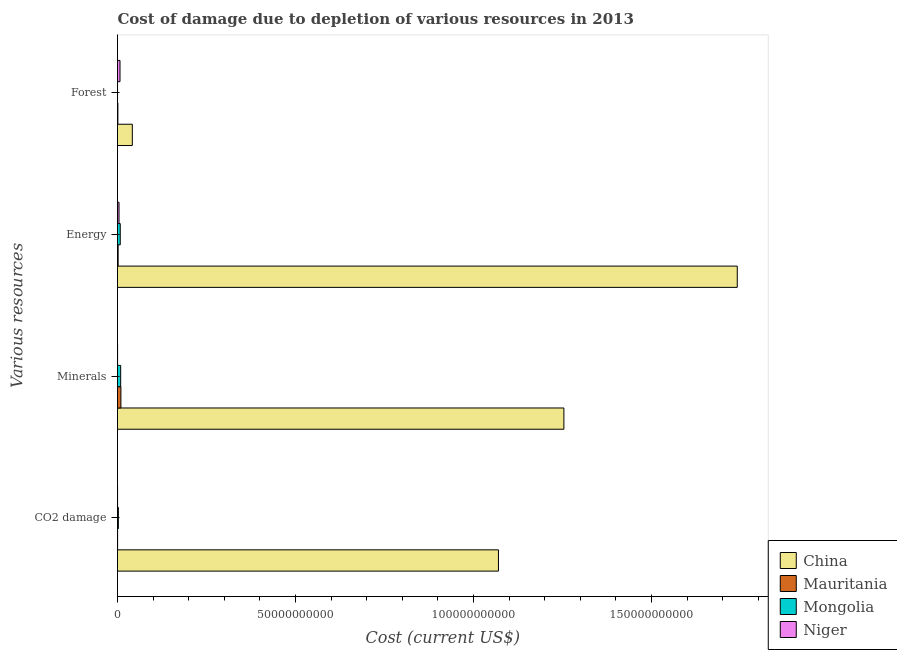How many different coloured bars are there?
Offer a terse response. 4. How many groups of bars are there?
Offer a very short reply. 4. What is the label of the 2nd group of bars from the top?
Keep it short and to the point. Energy. What is the cost of damage due to depletion of coal in Mongolia?
Your answer should be compact. 2.45e+08. Across all countries, what is the maximum cost of damage due to depletion of energy?
Offer a very short reply. 1.74e+11. Across all countries, what is the minimum cost of damage due to depletion of coal?
Provide a short and direct response. 1.70e+07. In which country was the cost of damage due to depletion of minerals minimum?
Ensure brevity in your answer.  Niger. What is the total cost of damage due to depletion of energy in the graph?
Give a very brief answer. 1.75e+11. What is the difference between the cost of damage due to depletion of forests in China and that in Mongolia?
Give a very brief answer. 4.15e+09. What is the difference between the cost of damage due to depletion of energy in Mongolia and the cost of damage due to depletion of minerals in Niger?
Your answer should be compact. 7.47e+08. What is the average cost of damage due to depletion of energy per country?
Ensure brevity in your answer.  4.39e+1. What is the difference between the cost of damage due to depletion of minerals and cost of damage due to depletion of coal in Mauritania?
Keep it short and to the point. 9.31e+08. In how many countries, is the cost of damage due to depletion of forests greater than 150000000000 US$?
Ensure brevity in your answer.  0. What is the ratio of the cost of damage due to depletion of minerals in Mauritania to that in Mongolia?
Your response must be concise. 1.08. What is the difference between the highest and the second highest cost of damage due to depletion of coal?
Keep it short and to the point. 1.07e+11. What is the difference between the highest and the lowest cost of damage due to depletion of forests?
Keep it short and to the point. 4.15e+09. In how many countries, is the cost of damage due to depletion of energy greater than the average cost of damage due to depletion of energy taken over all countries?
Give a very brief answer. 1. Is the sum of the cost of damage due to depletion of energy in Mongolia and Niger greater than the maximum cost of damage due to depletion of forests across all countries?
Provide a short and direct response. No. Is it the case that in every country, the sum of the cost of damage due to depletion of energy and cost of damage due to depletion of coal is greater than the sum of cost of damage due to depletion of minerals and cost of damage due to depletion of forests?
Offer a terse response. No. What does the 3rd bar from the top in Forest represents?
Give a very brief answer. Mauritania. What does the 2nd bar from the bottom in Forest represents?
Give a very brief answer. Mauritania. Is it the case that in every country, the sum of the cost of damage due to depletion of coal and cost of damage due to depletion of minerals is greater than the cost of damage due to depletion of energy?
Make the answer very short. No. Are all the bars in the graph horizontal?
Ensure brevity in your answer.  Yes. Are the values on the major ticks of X-axis written in scientific E-notation?
Make the answer very short. No. Does the graph contain grids?
Your answer should be very brief. No. Where does the legend appear in the graph?
Your answer should be compact. Bottom right. How are the legend labels stacked?
Provide a succinct answer. Vertical. What is the title of the graph?
Your response must be concise. Cost of damage due to depletion of various resources in 2013 . Does "Macao" appear as one of the legend labels in the graph?
Make the answer very short. No. What is the label or title of the X-axis?
Provide a succinct answer. Cost (current US$). What is the label or title of the Y-axis?
Your answer should be very brief. Various resources. What is the Cost (current US$) of China in CO2 damage?
Keep it short and to the point. 1.07e+11. What is the Cost (current US$) in Mauritania in CO2 damage?
Ensure brevity in your answer.  2.65e+07. What is the Cost (current US$) in Mongolia in CO2 damage?
Your answer should be very brief. 2.45e+08. What is the Cost (current US$) of Niger in CO2 damage?
Your response must be concise. 1.70e+07. What is the Cost (current US$) of China in Minerals?
Your answer should be very brief. 1.25e+11. What is the Cost (current US$) in Mauritania in Minerals?
Keep it short and to the point. 9.57e+08. What is the Cost (current US$) in Mongolia in Minerals?
Ensure brevity in your answer.  8.90e+08. What is the Cost (current US$) of Niger in Minerals?
Provide a short and direct response. 2.19e+07. What is the Cost (current US$) in China in Energy?
Your response must be concise. 1.74e+11. What is the Cost (current US$) of Mauritania in Energy?
Offer a terse response. 1.78e+08. What is the Cost (current US$) in Mongolia in Energy?
Ensure brevity in your answer.  7.69e+08. What is the Cost (current US$) in Niger in Energy?
Make the answer very short. 4.27e+08. What is the Cost (current US$) of China in Forest?
Keep it short and to the point. 4.16e+09. What is the Cost (current US$) in Mauritania in Forest?
Give a very brief answer. 1.03e+08. What is the Cost (current US$) of Mongolia in Forest?
Provide a succinct answer. 8.40e+06. What is the Cost (current US$) in Niger in Forest?
Give a very brief answer. 7.01e+08. Across all Various resources, what is the maximum Cost (current US$) in China?
Offer a very short reply. 1.74e+11. Across all Various resources, what is the maximum Cost (current US$) of Mauritania?
Your answer should be compact. 9.57e+08. Across all Various resources, what is the maximum Cost (current US$) of Mongolia?
Offer a terse response. 8.90e+08. Across all Various resources, what is the maximum Cost (current US$) in Niger?
Make the answer very short. 7.01e+08. Across all Various resources, what is the minimum Cost (current US$) of China?
Give a very brief answer. 4.16e+09. Across all Various resources, what is the minimum Cost (current US$) in Mauritania?
Your answer should be compact. 2.65e+07. Across all Various resources, what is the minimum Cost (current US$) in Mongolia?
Offer a very short reply. 8.40e+06. Across all Various resources, what is the minimum Cost (current US$) in Niger?
Your answer should be very brief. 1.70e+07. What is the total Cost (current US$) in China in the graph?
Give a very brief answer. 4.11e+11. What is the total Cost (current US$) in Mauritania in the graph?
Provide a short and direct response. 1.27e+09. What is the total Cost (current US$) in Mongolia in the graph?
Provide a short and direct response. 1.91e+09. What is the total Cost (current US$) of Niger in the graph?
Give a very brief answer. 1.17e+09. What is the difference between the Cost (current US$) of China in CO2 damage and that in Minerals?
Your response must be concise. -1.84e+1. What is the difference between the Cost (current US$) of Mauritania in CO2 damage and that in Minerals?
Provide a short and direct response. -9.31e+08. What is the difference between the Cost (current US$) of Mongolia in CO2 damage and that in Minerals?
Keep it short and to the point. -6.46e+08. What is the difference between the Cost (current US$) in Niger in CO2 damage and that in Minerals?
Provide a short and direct response. -4.85e+06. What is the difference between the Cost (current US$) of China in CO2 damage and that in Energy?
Make the answer very short. -6.71e+1. What is the difference between the Cost (current US$) in Mauritania in CO2 damage and that in Energy?
Your response must be concise. -1.52e+08. What is the difference between the Cost (current US$) of Mongolia in CO2 damage and that in Energy?
Offer a very short reply. -5.25e+08. What is the difference between the Cost (current US$) in Niger in CO2 damage and that in Energy?
Offer a very short reply. -4.10e+08. What is the difference between the Cost (current US$) of China in CO2 damage and that in Forest?
Your response must be concise. 1.03e+11. What is the difference between the Cost (current US$) in Mauritania in CO2 damage and that in Forest?
Provide a short and direct response. -7.63e+07. What is the difference between the Cost (current US$) of Mongolia in CO2 damage and that in Forest?
Ensure brevity in your answer.  2.36e+08. What is the difference between the Cost (current US$) in Niger in CO2 damage and that in Forest?
Keep it short and to the point. -6.84e+08. What is the difference between the Cost (current US$) in China in Minerals and that in Energy?
Provide a succinct answer. -4.87e+1. What is the difference between the Cost (current US$) of Mauritania in Minerals and that in Energy?
Give a very brief answer. 7.79e+08. What is the difference between the Cost (current US$) of Mongolia in Minerals and that in Energy?
Your answer should be compact. 1.21e+08. What is the difference between the Cost (current US$) of Niger in Minerals and that in Energy?
Make the answer very short. -4.05e+08. What is the difference between the Cost (current US$) in China in Minerals and that in Forest?
Your answer should be compact. 1.21e+11. What is the difference between the Cost (current US$) of Mauritania in Minerals and that in Forest?
Give a very brief answer. 8.55e+08. What is the difference between the Cost (current US$) of Mongolia in Minerals and that in Forest?
Your response must be concise. 8.82e+08. What is the difference between the Cost (current US$) of Niger in Minerals and that in Forest?
Give a very brief answer. -6.79e+08. What is the difference between the Cost (current US$) in China in Energy and that in Forest?
Provide a succinct answer. 1.70e+11. What is the difference between the Cost (current US$) of Mauritania in Energy and that in Forest?
Provide a short and direct response. 7.56e+07. What is the difference between the Cost (current US$) of Mongolia in Energy and that in Forest?
Ensure brevity in your answer.  7.61e+08. What is the difference between the Cost (current US$) in Niger in Energy and that in Forest?
Provide a short and direct response. -2.74e+08. What is the difference between the Cost (current US$) in China in CO2 damage and the Cost (current US$) in Mauritania in Minerals?
Provide a short and direct response. 1.06e+11. What is the difference between the Cost (current US$) in China in CO2 damage and the Cost (current US$) in Mongolia in Minerals?
Provide a succinct answer. 1.06e+11. What is the difference between the Cost (current US$) of China in CO2 damage and the Cost (current US$) of Niger in Minerals?
Offer a terse response. 1.07e+11. What is the difference between the Cost (current US$) in Mauritania in CO2 damage and the Cost (current US$) in Mongolia in Minerals?
Your response must be concise. -8.64e+08. What is the difference between the Cost (current US$) of Mauritania in CO2 damage and the Cost (current US$) of Niger in Minerals?
Provide a succinct answer. 4.59e+06. What is the difference between the Cost (current US$) in Mongolia in CO2 damage and the Cost (current US$) in Niger in Minerals?
Give a very brief answer. 2.23e+08. What is the difference between the Cost (current US$) of China in CO2 damage and the Cost (current US$) of Mauritania in Energy?
Provide a succinct answer. 1.07e+11. What is the difference between the Cost (current US$) of China in CO2 damage and the Cost (current US$) of Mongolia in Energy?
Keep it short and to the point. 1.06e+11. What is the difference between the Cost (current US$) in China in CO2 damage and the Cost (current US$) in Niger in Energy?
Your answer should be compact. 1.07e+11. What is the difference between the Cost (current US$) in Mauritania in CO2 damage and the Cost (current US$) in Mongolia in Energy?
Your response must be concise. -7.43e+08. What is the difference between the Cost (current US$) in Mauritania in CO2 damage and the Cost (current US$) in Niger in Energy?
Keep it short and to the point. -4.01e+08. What is the difference between the Cost (current US$) in Mongolia in CO2 damage and the Cost (current US$) in Niger in Energy?
Offer a very short reply. -1.83e+08. What is the difference between the Cost (current US$) of China in CO2 damage and the Cost (current US$) of Mauritania in Forest?
Your answer should be compact. 1.07e+11. What is the difference between the Cost (current US$) in China in CO2 damage and the Cost (current US$) in Mongolia in Forest?
Your answer should be compact. 1.07e+11. What is the difference between the Cost (current US$) of China in CO2 damage and the Cost (current US$) of Niger in Forest?
Ensure brevity in your answer.  1.06e+11. What is the difference between the Cost (current US$) of Mauritania in CO2 damage and the Cost (current US$) of Mongolia in Forest?
Keep it short and to the point. 1.81e+07. What is the difference between the Cost (current US$) in Mauritania in CO2 damage and the Cost (current US$) in Niger in Forest?
Make the answer very short. -6.75e+08. What is the difference between the Cost (current US$) of Mongolia in CO2 damage and the Cost (current US$) of Niger in Forest?
Keep it short and to the point. -4.57e+08. What is the difference between the Cost (current US$) in China in Minerals and the Cost (current US$) in Mauritania in Energy?
Give a very brief answer. 1.25e+11. What is the difference between the Cost (current US$) in China in Minerals and the Cost (current US$) in Mongolia in Energy?
Your answer should be very brief. 1.25e+11. What is the difference between the Cost (current US$) in China in Minerals and the Cost (current US$) in Niger in Energy?
Give a very brief answer. 1.25e+11. What is the difference between the Cost (current US$) in Mauritania in Minerals and the Cost (current US$) in Mongolia in Energy?
Keep it short and to the point. 1.88e+08. What is the difference between the Cost (current US$) of Mauritania in Minerals and the Cost (current US$) of Niger in Energy?
Give a very brief answer. 5.30e+08. What is the difference between the Cost (current US$) in Mongolia in Minerals and the Cost (current US$) in Niger in Energy?
Provide a short and direct response. 4.63e+08. What is the difference between the Cost (current US$) in China in Minerals and the Cost (current US$) in Mauritania in Forest?
Offer a very short reply. 1.25e+11. What is the difference between the Cost (current US$) of China in Minerals and the Cost (current US$) of Mongolia in Forest?
Ensure brevity in your answer.  1.25e+11. What is the difference between the Cost (current US$) of China in Minerals and the Cost (current US$) of Niger in Forest?
Offer a very short reply. 1.25e+11. What is the difference between the Cost (current US$) in Mauritania in Minerals and the Cost (current US$) in Mongolia in Forest?
Keep it short and to the point. 9.49e+08. What is the difference between the Cost (current US$) in Mauritania in Minerals and the Cost (current US$) in Niger in Forest?
Give a very brief answer. 2.56e+08. What is the difference between the Cost (current US$) of Mongolia in Minerals and the Cost (current US$) of Niger in Forest?
Offer a terse response. 1.89e+08. What is the difference between the Cost (current US$) of China in Energy and the Cost (current US$) of Mauritania in Forest?
Your response must be concise. 1.74e+11. What is the difference between the Cost (current US$) of China in Energy and the Cost (current US$) of Mongolia in Forest?
Provide a succinct answer. 1.74e+11. What is the difference between the Cost (current US$) of China in Energy and the Cost (current US$) of Niger in Forest?
Ensure brevity in your answer.  1.73e+11. What is the difference between the Cost (current US$) of Mauritania in Energy and the Cost (current US$) of Mongolia in Forest?
Keep it short and to the point. 1.70e+08. What is the difference between the Cost (current US$) of Mauritania in Energy and the Cost (current US$) of Niger in Forest?
Give a very brief answer. -5.23e+08. What is the difference between the Cost (current US$) of Mongolia in Energy and the Cost (current US$) of Niger in Forest?
Your answer should be very brief. 6.81e+07. What is the average Cost (current US$) of China per Various resources?
Keep it short and to the point. 1.03e+11. What is the average Cost (current US$) of Mauritania per Various resources?
Provide a succinct answer. 3.16e+08. What is the average Cost (current US$) of Mongolia per Various resources?
Keep it short and to the point. 4.78e+08. What is the average Cost (current US$) in Niger per Various resources?
Provide a short and direct response. 2.92e+08. What is the difference between the Cost (current US$) in China and Cost (current US$) in Mauritania in CO2 damage?
Your answer should be very brief. 1.07e+11. What is the difference between the Cost (current US$) of China and Cost (current US$) of Mongolia in CO2 damage?
Your answer should be very brief. 1.07e+11. What is the difference between the Cost (current US$) of China and Cost (current US$) of Niger in CO2 damage?
Provide a succinct answer. 1.07e+11. What is the difference between the Cost (current US$) of Mauritania and Cost (current US$) of Mongolia in CO2 damage?
Keep it short and to the point. -2.18e+08. What is the difference between the Cost (current US$) in Mauritania and Cost (current US$) in Niger in CO2 damage?
Your answer should be very brief. 9.44e+06. What is the difference between the Cost (current US$) of Mongolia and Cost (current US$) of Niger in CO2 damage?
Give a very brief answer. 2.28e+08. What is the difference between the Cost (current US$) in China and Cost (current US$) in Mauritania in Minerals?
Offer a terse response. 1.24e+11. What is the difference between the Cost (current US$) in China and Cost (current US$) in Mongolia in Minerals?
Your response must be concise. 1.25e+11. What is the difference between the Cost (current US$) of China and Cost (current US$) of Niger in Minerals?
Provide a succinct answer. 1.25e+11. What is the difference between the Cost (current US$) in Mauritania and Cost (current US$) in Mongolia in Minerals?
Offer a very short reply. 6.70e+07. What is the difference between the Cost (current US$) of Mauritania and Cost (current US$) of Niger in Minerals?
Your answer should be very brief. 9.36e+08. What is the difference between the Cost (current US$) of Mongolia and Cost (current US$) of Niger in Minerals?
Offer a very short reply. 8.69e+08. What is the difference between the Cost (current US$) in China and Cost (current US$) in Mauritania in Energy?
Provide a short and direct response. 1.74e+11. What is the difference between the Cost (current US$) in China and Cost (current US$) in Mongolia in Energy?
Offer a very short reply. 1.73e+11. What is the difference between the Cost (current US$) of China and Cost (current US$) of Niger in Energy?
Ensure brevity in your answer.  1.74e+11. What is the difference between the Cost (current US$) in Mauritania and Cost (current US$) in Mongolia in Energy?
Provide a short and direct response. -5.91e+08. What is the difference between the Cost (current US$) of Mauritania and Cost (current US$) of Niger in Energy?
Your answer should be very brief. -2.49e+08. What is the difference between the Cost (current US$) in Mongolia and Cost (current US$) in Niger in Energy?
Your answer should be compact. 3.42e+08. What is the difference between the Cost (current US$) of China and Cost (current US$) of Mauritania in Forest?
Your answer should be very brief. 4.06e+09. What is the difference between the Cost (current US$) in China and Cost (current US$) in Mongolia in Forest?
Offer a very short reply. 4.15e+09. What is the difference between the Cost (current US$) in China and Cost (current US$) in Niger in Forest?
Offer a terse response. 3.46e+09. What is the difference between the Cost (current US$) of Mauritania and Cost (current US$) of Mongolia in Forest?
Ensure brevity in your answer.  9.44e+07. What is the difference between the Cost (current US$) in Mauritania and Cost (current US$) in Niger in Forest?
Make the answer very short. -5.98e+08. What is the difference between the Cost (current US$) of Mongolia and Cost (current US$) of Niger in Forest?
Your answer should be very brief. -6.93e+08. What is the ratio of the Cost (current US$) of China in CO2 damage to that in Minerals?
Keep it short and to the point. 0.85. What is the ratio of the Cost (current US$) of Mauritania in CO2 damage to that in Minerals?
Offer a very short reply. 0.03. What is the ratio of the Cost (current US$) of Mongolia in CO2 damage to that in Minerals?
Your answer should be very brief. 0.27. What is the ratio of the Cost (current US$) in Niger in CO2 damage to that in Minerals?
Your answer should be very brief. 0.78. What is the ratio of the Cost (current US$) of China in CO2 damage to that in Energy?
Keep it short and to the point. 0.61. What is the ratio of the Cost (current US$) in Mauritania in CO2 damage to that in Energy?
Offer a very short reply. 0.15. What is the ratio of the Cost (current US$) of Mongolia in CO2 damage to that in Energy?
Give a very brief answer. 0.32. What is the ratio of the Cost (current US$) in Niger in CO2 damage to that in Energy?
Your answer should be compact. 0.04. What is the ratio of the Cost (current US$) of China in CO2 damage to that in Forest?
Your answer should be very brief. 25.7. What is the ratio of the Cost (current US$) of Mauritania in CO2 damage to that in Forest?
Give a very brief answer. 0.26. What is the ratio of the Cost (current US$) in Mongolia in CO2 damage to that in Forest?
Give a very brief answer. 29.13. What is the ratio of the Cost (current US$) of Niger in CO2 damage to that in Forest?
Make the answer very short. 0.02. What is the ratio of the Cost (current US$) in China in Minerals to that in Energy?
Make the answer very short. 0.72. What is the ratio of the Cost (current US$) of Mauritania in Minerals to that in Energy?
Provide a succinct answer. 5.37. What is the ratio of the Cost (current US$) in Mongolia in Minerals to that in Energy?
Make the answer very short. 1.16. What is the ratio of the Cost (current US$) in Niger in Minerals to that in Energy?
Provide a succinct answer. 0.05. What is the ratio of the Cost (current US$) of China in Minerals to that in Forest?
Your answer should be very brief. 30.12. What is the ratio of the Cost (current US$) of Mauritania in Minerals to that in Forest?
Your answer should be compact. 9.31. What is the ratio of the Cost (current US$) of Mongolia in Minerals to that in Forest?
Your answer should be compact. 106.03. What is the ratio of the Cost (current US$) of Niger in Minerals to that in Forest?
Make the answer very short. 0.03. What is the ratio of the Cost (current US$) of China in Energy to that in Forest?
Provide a short and direct response. 41.82. What is the ratio of the Cost (current US$) of Mauritania in Energy to that in Forest?
Your response must be concise. 1.74. What is the ratio of the Cost (current US$) in Mongolia in Energy to that in Forest?
Offer a terse response. 91.6. What is the ratio of the Cost (current US$) in Niger in Energy to that in Forest?
Ensure brevity in your answer.  0.61. What is the difference between the highest and the second highest Cost (current US$) in China?
Your answer should be compact. 4.87e+1. What is the difference between the highest and the second highest Cost (current US$) of Mauritania?
Provide a succinct answer. 7.79e+08. What is the difference between the highest and the second highest Cost (current US$) in Mongolia?
Offer a terse response. 1.21e+08. What is the difference between the highest and the second highest Cost (current US$) in Niger?
Provide a succinct answer. 2.74e+08. What is the difference between the highest and the lowest Cost (current US$) in China?
Offer a terse response. 1.70e+11. What is the difference between the highest and the lowest Cost (current US$) in Mauritania?
Offer a terse response. 9.31e+08. What is the difference between the highest and the lowest Cost (current US$) of Mongolia?
Your answer should be very brief. 8.82e+08. What is the difference between the highest and the lowest Cost (current US$) in Niger?
Offer a very short reply. 6.84e+08. 